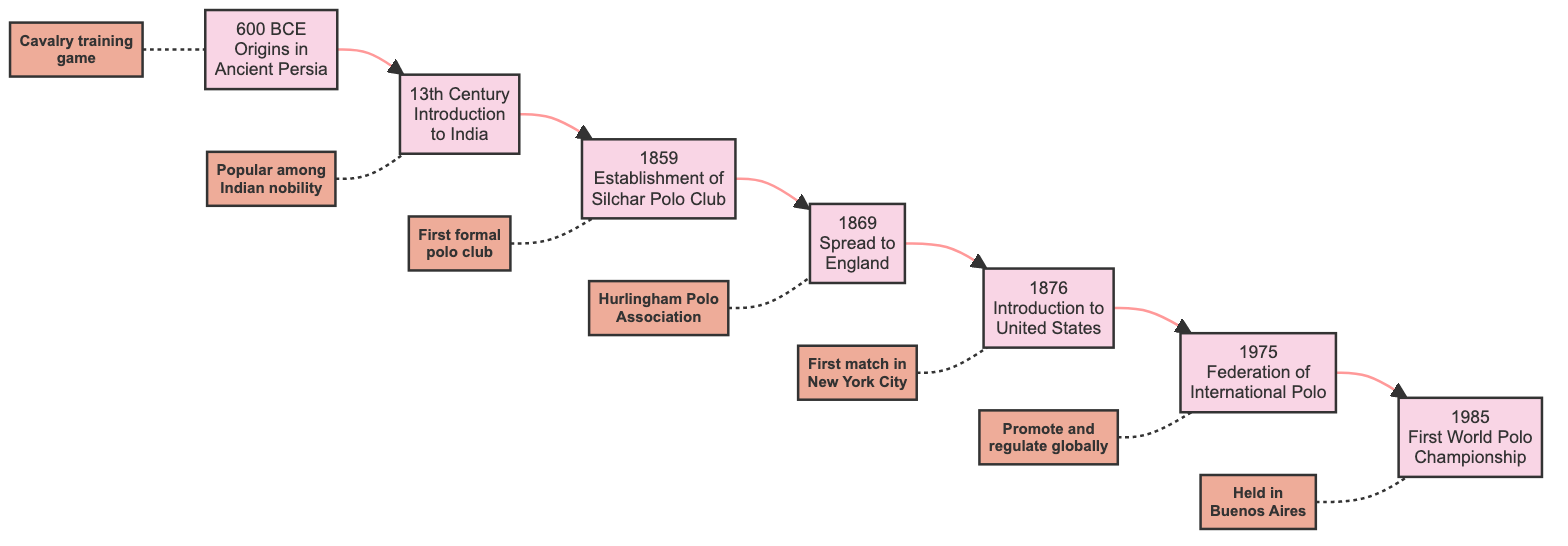What year marks the origin of polo? The diagram indicates that polo originated in "600 BCE." This is explicitly mentioned in the first node, which is directly connected to the subsequent event in the flowchart.
Answer: 600 BCE Which event occurred in the 13th Century? The node corresponding to the 13th Century shows the event "Introduction to India." This is a clear visual connection from the origin of polo in the previous node.
Answer: Introduction to India How many key milestones are represented in the flowchart? Counting the nodes from the origin to the final event, there are seven milestones depicted in the flowchart, each one corresponding to a year and event.
Answer: 7 What was established in 1859? The node for 1859 specifies "Establishment of the Silchar Polo Club." This is directly stated in that specific node in the flowchart, allowing for a straightforward answer.
Answer: Establishment of Silchar Polo Club Which event follows the establishment of the Silchar Polo Club? Referring to the flowchart, the event that comes after "Establishment of the Silchar Polo Club (1859)" is "Spread to England (1869)," indicating a sequential flow from one event to the next.
Answer: Spread to England What significant development in polo occurred in 1975? The flowchart clearly states that the "Federation of International Polo Formation" took place in 1975, as noted in the relevant node. This indicates a notable point in the sport's global regulation and promotion.
Answer: Federation of International Polo Formation What was the significance of the First World Polo Championship held in 1985? From the information in the flowchart, the inaugural World Polo Championship is highlighted as being "Held in Buenos Aires," which reflects the global reach of the sport at that time.
Answer: Held in Buenos Aires What event connected the spread of polo from India to England? The transition from India to England in the historical timeline of polo is captured by the "Spread to England" event in the flowchart, which follows the introduction of polo to India.
Answer: Spread to England 